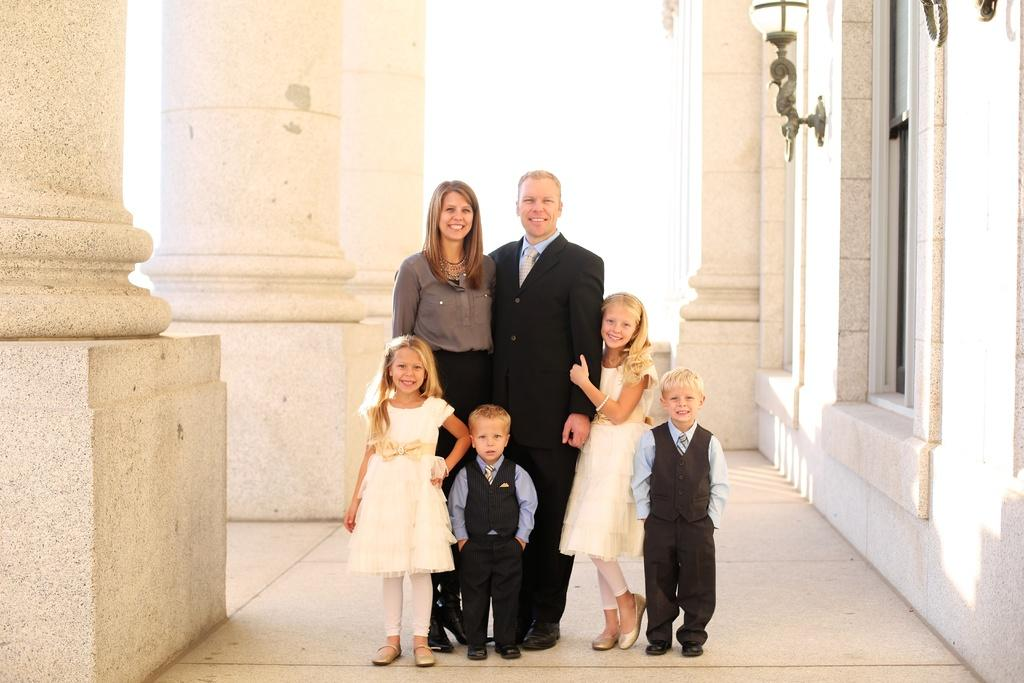How many people are in the image? There are a man, a woman, and four children in the image, making a total of six people. What are the people in the image doing? The people are standing and posing for a photo. What architectural features can be seen in the image? There are pillars, walls, and a window visible in the image. What is the purpose of the lamp in the image? The lamp in the image is likely for providing light. What type of mist can be seen in the image? There is no mist present in the image; it is an indoor scene with people posing for a photo. 